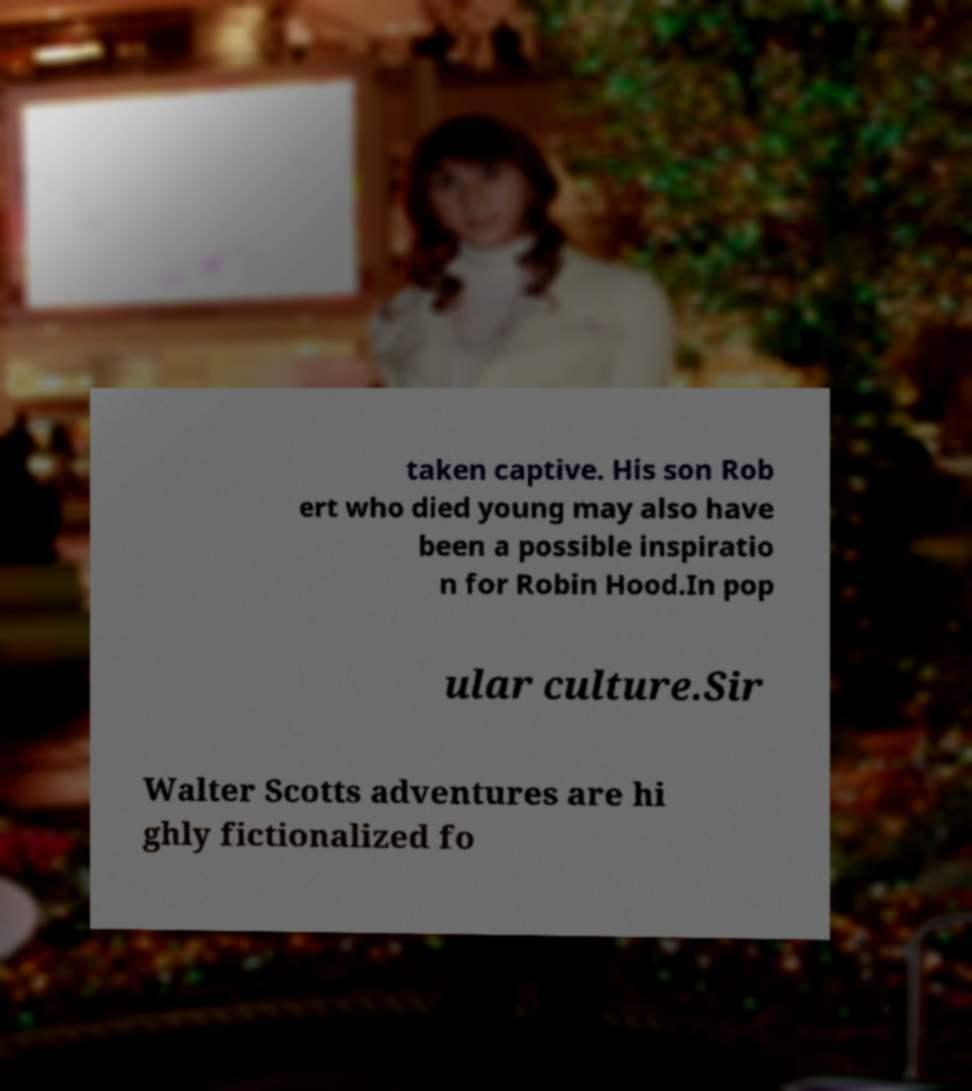I need the written content from this picture converted into text. Can you do that? taken captive. His son Rob ert who died young may also have been a possible inspiratio n for Robin Hood.In pop ular culture.Sir Walter Scotts adventures are hi ghly fictionalized fo 